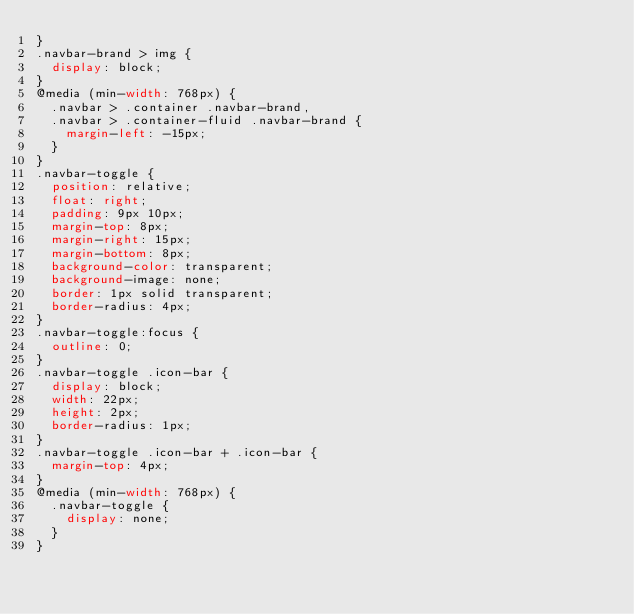<code> <loc_0><loc_0><loc_500><loc_500><_CSS_>}
.navbar-brand > img {
  display: block;
}
@media (min-width: 768px) {
  .navbar > .container .navbar-brand,
  .navbar > .container-fluid .navbar-brand {
    margin-left: -15px;
  }
}
.navbar-toggle {
  position: relative;
  float: right;
  padding: 9px 10px;
  margin-top: 8px;
  margin-right: 15px;
  margin-bottom: 8px;
  background-color: transparent;
  background-image: none;
  border: 1px solid transparent;
  border-radius: 4px;
}
.navbar-toggle:focus {
  outline: 0;
}
.navbar-toggle .icon-bar {
  display: block;
  width: 22px;
  height: 2px;
  border-radius: 1px;
}
.navbar-toggle .icon-bar + .icon-bar {
  margin-top: 4px;
}
@media (min-width: 768px) {
  .navbar-toggle {
    display: none;
  }
}</code> 